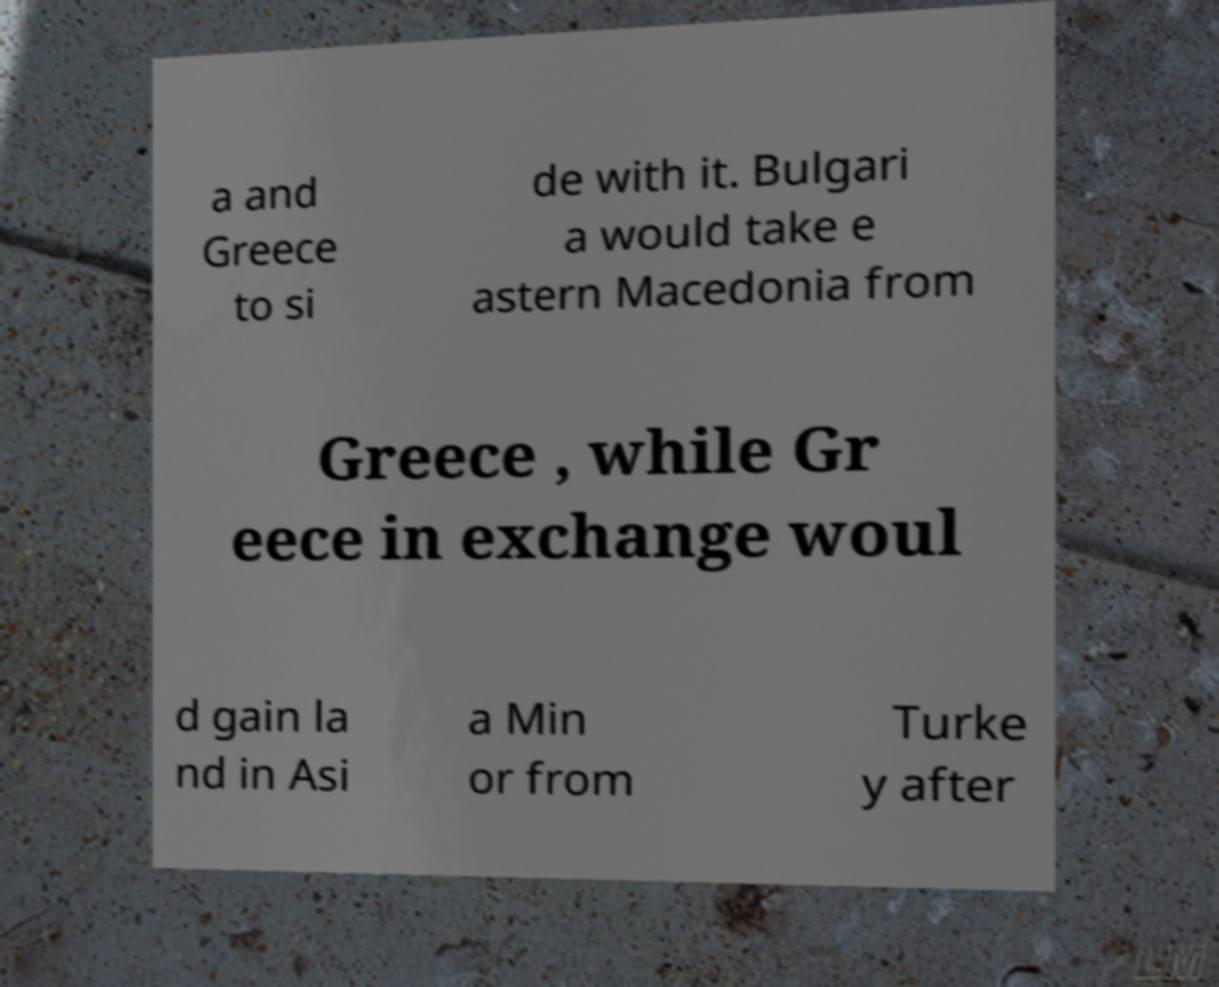Please read and relay the text visible in this image. What does it say? a and Greece to si de with it. Bulgari a would take e astern Macedonia from Greece , while Gr eece in exchange woul d gain la nd in Asi a Min or from Turke y after 